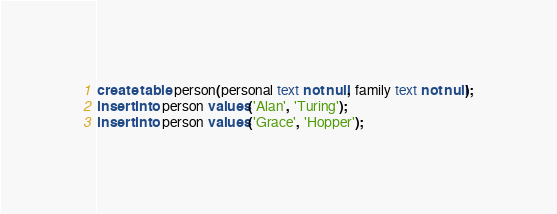<code> <loc_0><loc_0><loc_500><loc_500><_SQL_>create table person(personal text not null, family text not null);
insert into person values('Alan', 'Turing');
insert into person values('Grace', 'Hopper');
</code> 